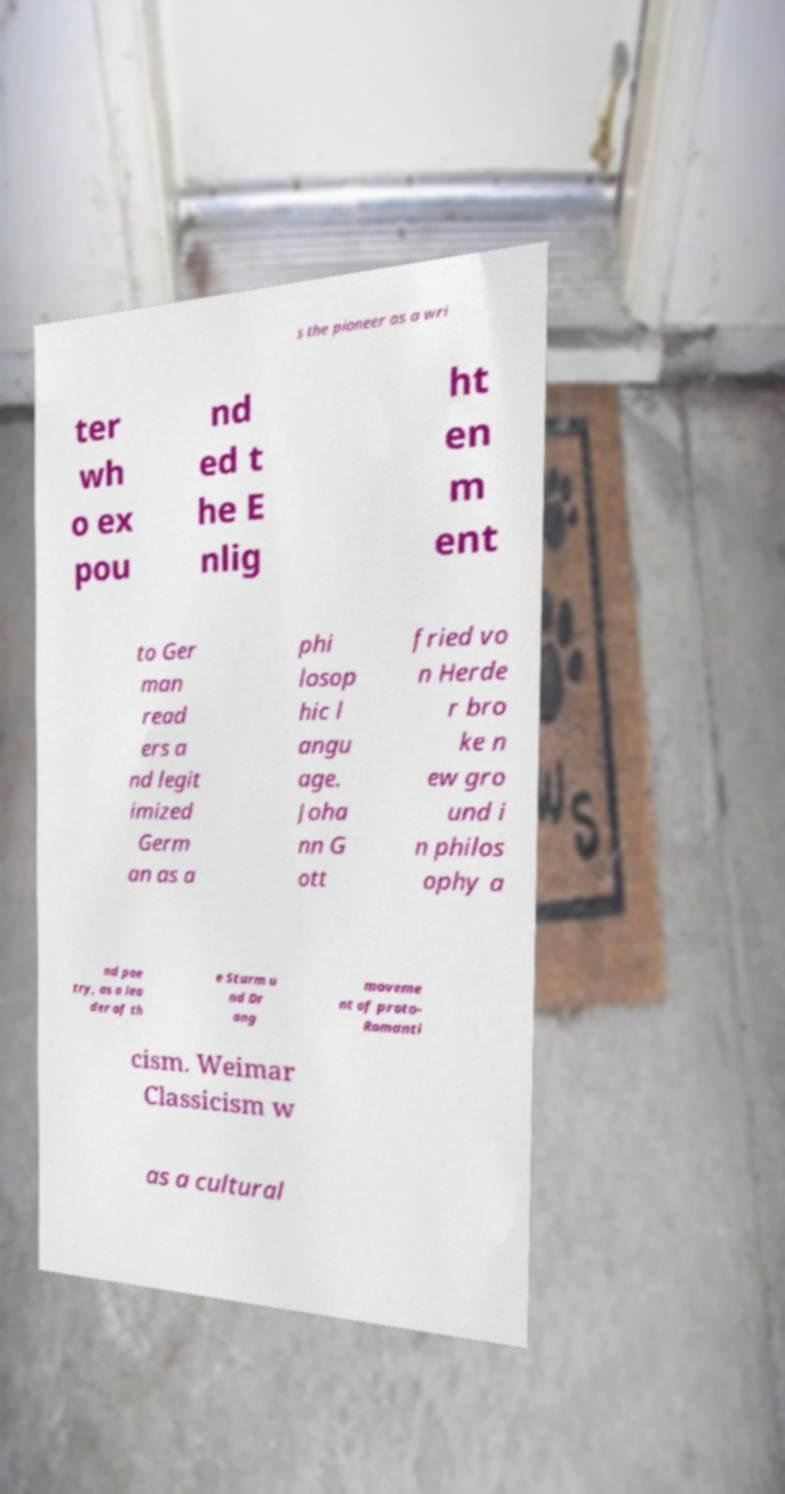Could you extract and type out the text from this image? s the pioneer as a wri ter wh o ex pou nd ed t he E nlig ht en m ent to Ger man read ers a nd legit imized Germ an as a phi losop hic l angu age. Joha nn G ott fried vo n Herde r bro ke n ew gro und i n philos ophy a nd poe try, as a lea der of th e Sturm u nd Dr ang moveme nt of proto- Romanti cism. Weimar Classicism w as a cultural 